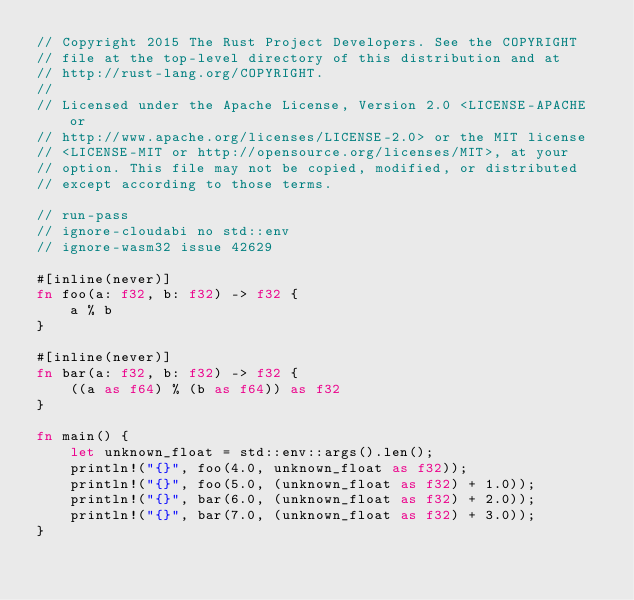Convert code to text. <code><loc_0><loc_0><loc_500><loc_500><_Rust_>// Copyright 2015 The Rust Project Developers. See the COPYRIGHT
// file at the top-level directory of this distribution and at
// http://rust-lang.org/COPYRIGHT.
//
// Licensed under the Apache License, Version 2.0 <LICENSE-APACHE or
// http://www.apache.org/licenses/LICENSE-2.0> or the MIT license
// <LICENSE-MIT or http://opensource.org/licenses/MIT>, at your
// option. This file may not be copied, modified, or distributed
// except according to those terms.

// run-pass
// ignore-cloudabi no std::env
// ignore-wasm32 issue 42629

#[inline(never)]
fn foo(a: f32, b: f32) -> f32 {
    a % b
}

#[inline(never)]
fn bar(a: f32, b: f32) -> f32 {
    ((a as f64) % (b as f64)) as f32
}

fn main() {
    let unknown_float = std::env::args().len();
    println!("{}", foo(4.0, unknown_float as f32));
    println!("{}", foo(5.0, (unknown_float as f32) + 1.0));
    println!("{}", bar(6.0, (unknown_float as f32) + 2.0));
    println!("{}", bar(7.0, (unknown_float as f32) + 3.0));
}
</code> 